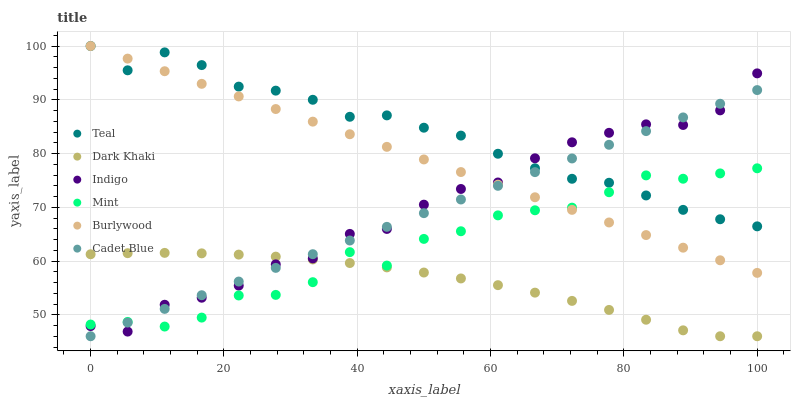Does Dark Khaki have the minimum area under the curve?
Answer yes or no. Yes. Does Teal have the maximum area under the curve?
Answer yes or no. Yes. Does Indigo have the minimum area under the curve?
Answer yes or no. No. Does Indigo have the maximum area under the curve?
Answer yes or no. No. Is Burlywood the smoothest?
Answer yes or no. Yes. Is Mint the roughest?
Answer yes or no. Yes. Is Indigo the smoothest?
Answer yes or no. No. Is Indigo the roughest?
Answer yes or no. No. Does Cadet Blue have the lowest value?
Answer yes or no. Yes. Does Indigo have the lowest value?
Answer yes or no. No. Does Teal have the highest value?
Answer yes or no. Yes. Does Indigo have the highest value?
Answer yes or no. No. Is Dark Khaki less than Teal?
Answer yes or no. Yes. Is Burlywood greater than Dark Khaki?
Answer yes or no. Yes. Does Burlywood intersect Mint?
Answer yes or no. Yes. Is Burlywood less than Mint?
Answer yes or no. No. Is Burlywood greater than Mint?
Answer yes or no. No. Does Dark Khaki intersect Teal?
Answer yes or no. No. 